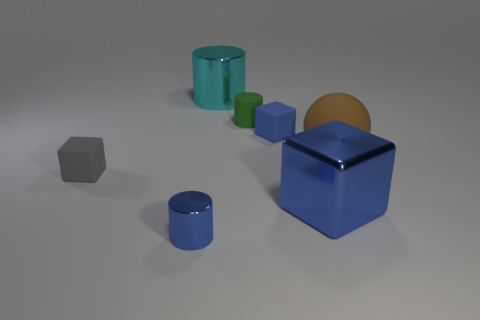How many things are either rubber blocks that are on the right side of the small green thing or gray matte cubes?
Ensure brevity in your answer.  2. There is a small cube that is right of the large cyan cylinder; does it have the same color as the big metal cube?
Your response must be concise. Yes. What is the size of the cyan thing that is the same shape as the tiny green thing?
Ensure brevity in your answer.  Large. What color is the small cube right of the small blue object that is in front of the ball in front of the blue rubber cube?
Your answer should be compact. Blue. Do the large cylinder and the blue cylinder have the same material?
Make the answer very short. Yes. There is a cube to the left of the shiny thing that is behind the green matte cylinder; are there any objects behind it?
Provide a short and direct response. Yes. Is the tiny shiny cylinder the same color as the large metallic cube?
Your answer should be very brief. Yes. Is the number of gray objects less than the number of matte objects?
Your answer should be very brief. Yes. Are the blue cube behind the small gray object and the cylinder behind the small green thing made of the same material?
Offer a terse response. No. Are there fewer small blue shiny objects that are right of the blue metallic cube than tiny red cylinders?
Your response must be concise. No. 